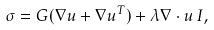Convert formula to latex. <formula><loc_0><loc_0><loc_500><loc_500>\sigma = G ( \nabla { u } + \nabla { u } ^ { T } ) + \lambda \nabla \cdot { u } \, { I } ,</formula> 